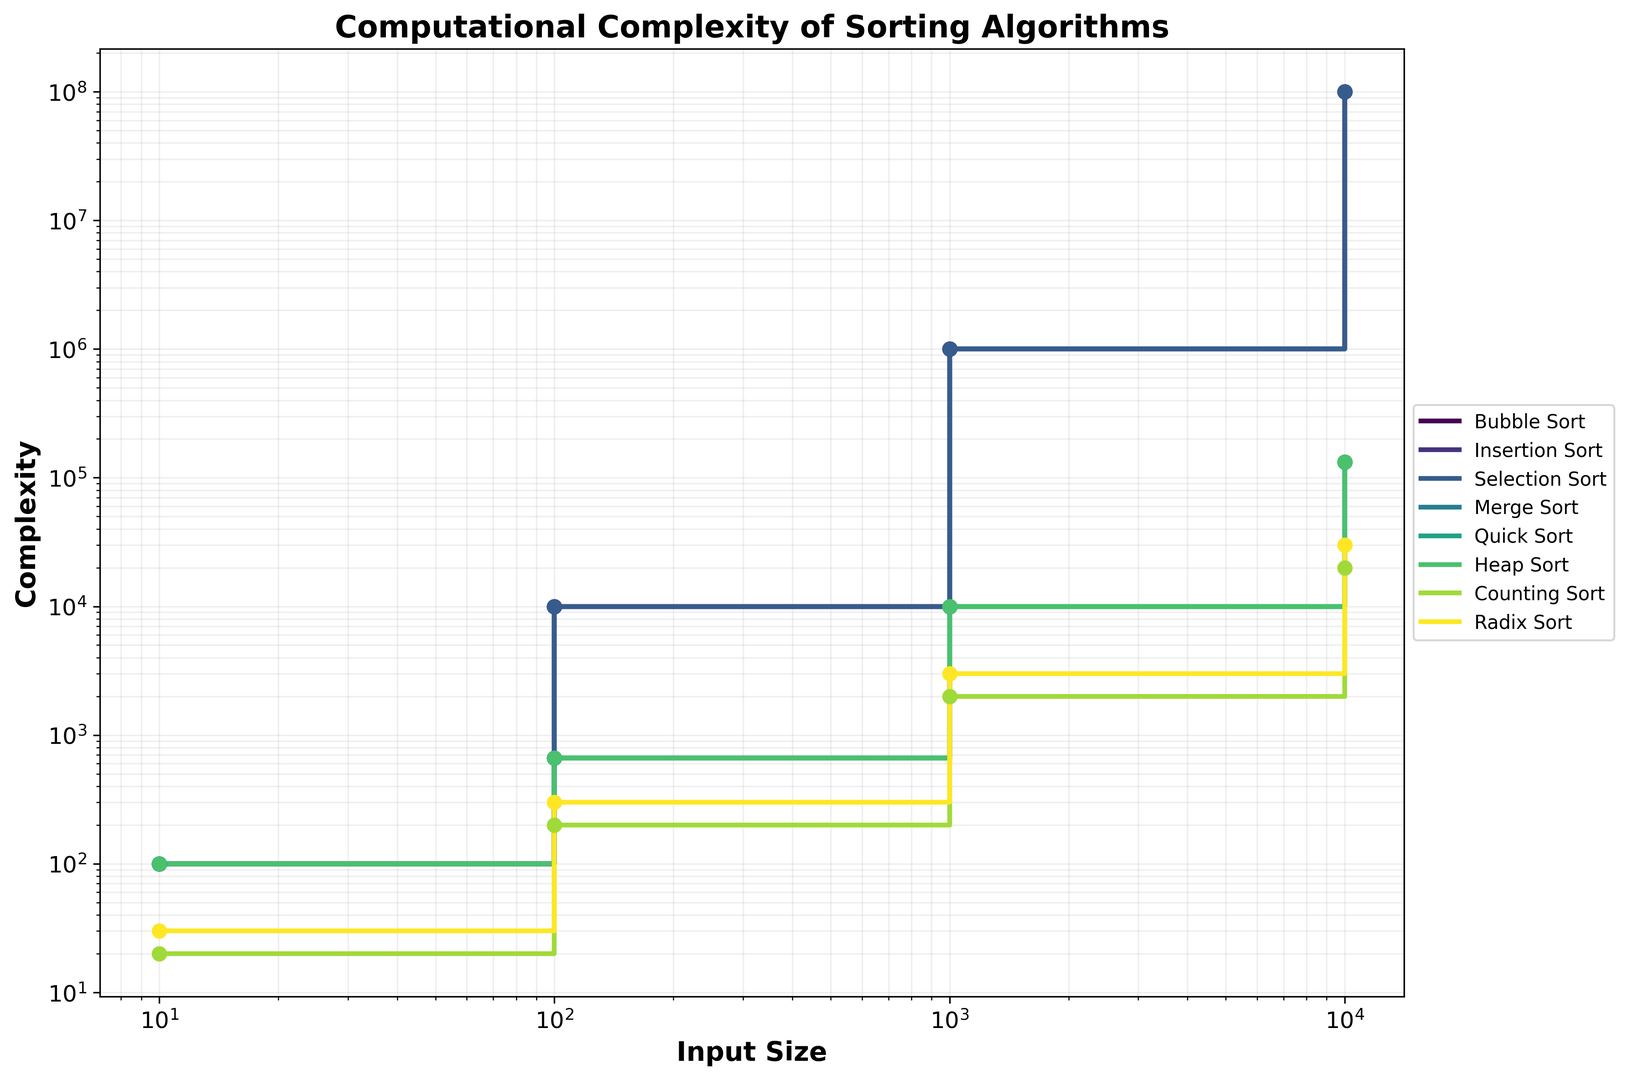What is the key observation from comparing Bubble Sort and Merge Sort? By looking at the graph, observe that Bubble Sort's complexity increases much more rapidly compared to Merge Sort as input size grows. For input size 10,000, Bubble Sort reaches a complexity of 100,000,000, while Merge Sort is around 132,877, indicating Merge Sort is more efficient.
Answer: Merge Sort is significantly more efficient than Bubble Sort How does Counting Sort's complexity compare to Quick Sort for an input size of 1000? For input size 1000, notice that Counting Sort's complexity is 2000, while Quick Sort's complexity is 9966. Therefore, Counting Sort has a lower complexity.
Answer: Counting Sort has a lower complexity Which algorithm shows the least increase in complexity as the input size grows? Radix Sort shows the smallest step-wise increases. For input sizes 10, 100, 1000, and 10,000, its complexities are 30, 300, 3000, and 30,000, respectively.
Answer: Radix Sort For input sizes 100 and 1000, which algorithm shows the largest difference in complexity? For input size 100, the highest complexity is 10,000 (Bubble Sort, Insertion Sort, Selection Sort). For input size 1000, the highest complexity is 1,000,000 for the same algorithms, yielding a difference of 990,000.
Answer: Bubble Sort, Insertion Sort, Selection Sort Which algorithms exhibit a quadratic growth pattern in complexity? By examining the plot, Bubble Sort, Insertion Sort, and Selection Sort all exhibit quadratic growth (O(n^2)), as seen by the pattern of their step-wise increases.
Answer: Bubble Sort, Insertion Sort, Selection Sort How does Heap Sort’s computational complexity compare to Counting Sort for an input size of 10,000? At input size 10,000, Heap Sort's complexity is 132,877 while Counting Sort’s complexity is 20,000. Therefore, Counting Sort is more efficient.
Answer: Counting Sort is more efficient What happens to the complexity of Quick Sort from input size 10 to 10,000? For Quick Sort, the complexity increases from 100 at input size 10 to 132,877 at input size 10,000, showing logarithmic growth.
Answer: It increases significantly Which algorithm has the highest complexity for an input size of 10? For input size 10, all algorithms' complexities converge closely, with Bubble Sort, Insertion Sort, Selection Sort, Merge Sort, Quick Sort, and Heap Sort having complexities of 100, but Counting Sort and Radix Sort are even lower (20 and 30 respectively). Thus, highest complexity is 100.
Answer: Bubble Sort, Insertion Sort, Selection Sort, Merge Sort, Quick Sort, Heap Sort By what factor does Insertion Sort's complexity increase from an input size of 100 to 10000? For Insertion Sort, complexity moves from 10,000 to 100,000,000. The increase factor is 100,000,000 / 10,000, which equals 10,000.
Answer: 10,000 